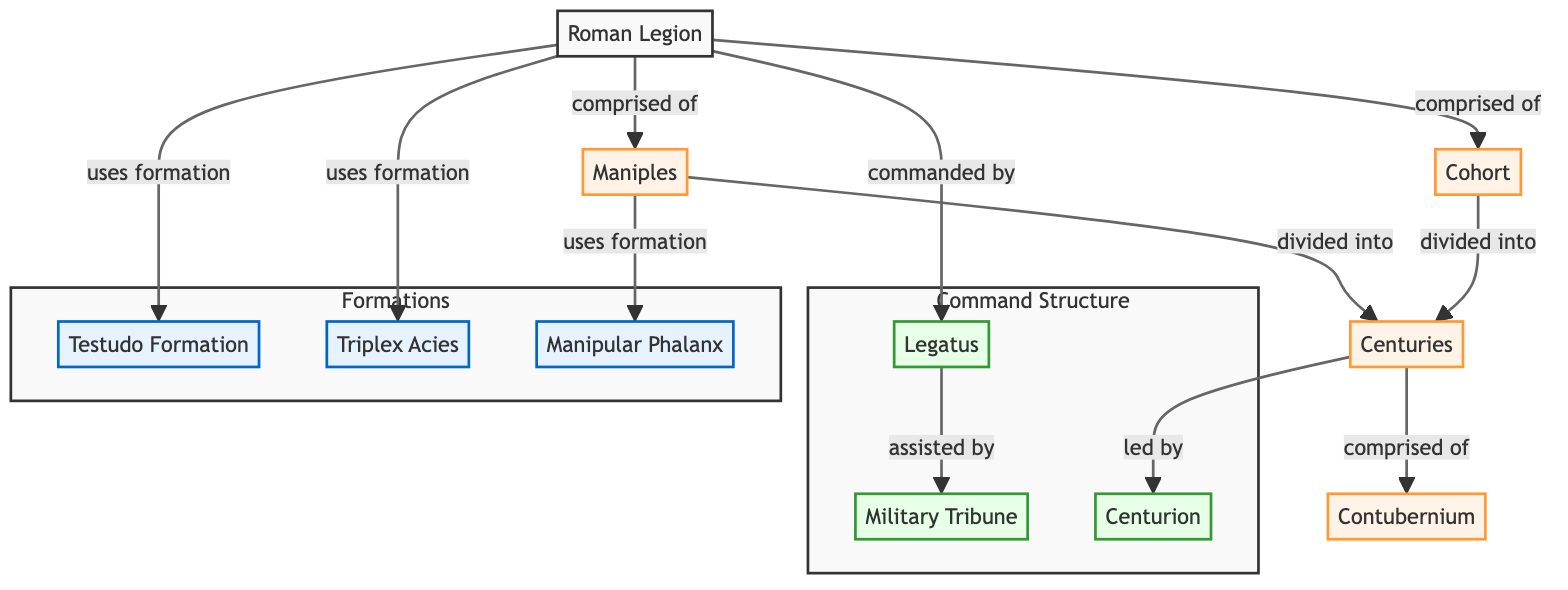What are the two main divisions of the Roman Legion? The diagram shows two main divisions: "Maniples" and "Cohort." Each of these divisions comprises smaller units within the legion.
Answer: Maniples, Cohort Who commands the Roman Legion? According to the diagram, the "Legatus" is the commander of the Roman Legion.
Answer: Legatus How many layers of command are present in the Roman Legion? By examining the Command Structure section, it shows three ranks: "Legatus," "Tribune," and "Centurion," indicating there are three layers.
Answer: 3 Which formation is specifically associated with the "Maniples"? The diagram indicates that "Manipular Phalanx" is the formation used by the Maniples.
Answer: Manipular Phalanx What unit is comprised of multiple "Centuries"? The diagram illustrates that both "Maniples" and "Cohorts" are divided into "Centuries," thus they are the units comprising multiple Centuries.
Answer: Maniples, Cohorts What is the relationship between the "Centuries" and "Contubernium"? The diagram shows that "Centuries" are comprised of "Contubernium," indicating a hierarchical structure where Contubernium is a smaller unit within a Century.
Answer: Comprised of Which formations does the Roman Legion employ? The diagram states three formations used by the Roman Legion: "Testudo," "Triplex Acies," and "Manipular Phalanx."
Answer: Testudo, Triplex Acies, Manipular Phalanx What role does the "Tribune" play in the Roman Legion? Referencing the diagram, the "Tribune" assists the "Legatus," indicating a supportive role within the command structure.
Answer: Assists How is the "Testudo Formation" categorized in the diagram? The diagram places the "Testudo Formation" within the subgraph labeled "Formations," indicating it is a type of combat formation used by the legion.
Answer: Formation How many types of formations does the Roman Legion use according to the diagram? The diagram lists three specific formations under the Formations subgraph: "Testudo," "Triplex Acies," and "Manipular Phalanx," totaling three types of formations.
Answer: 3 